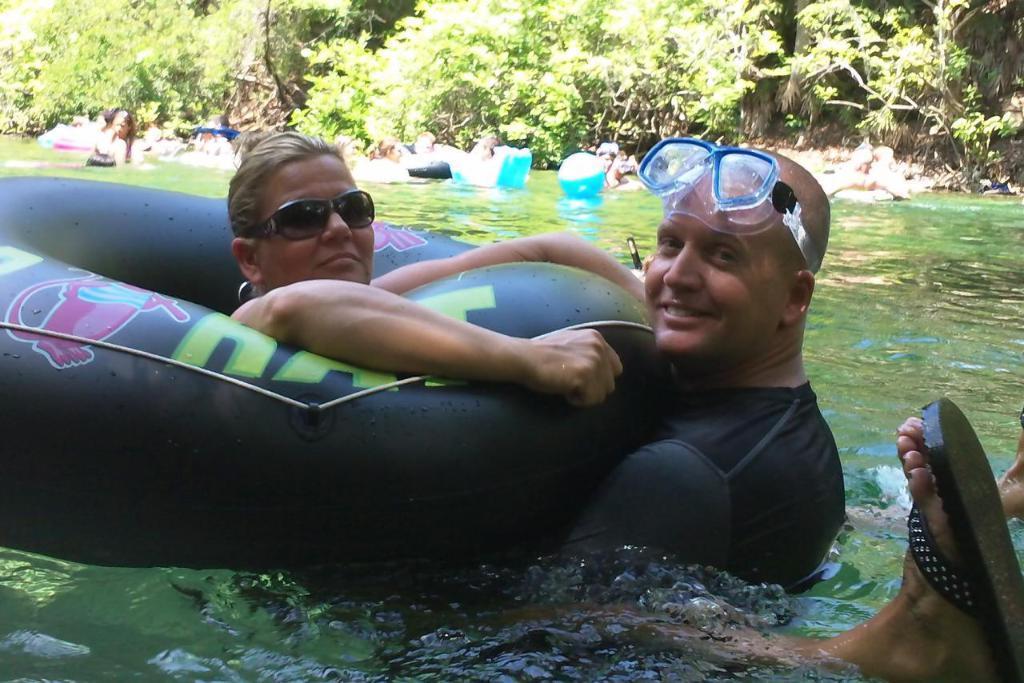Can you describe this image briefly? In this picture we can see the man and woman in the swimming pool with black color tube, smiling and giving pose to the camera. Behind there are some trees. 